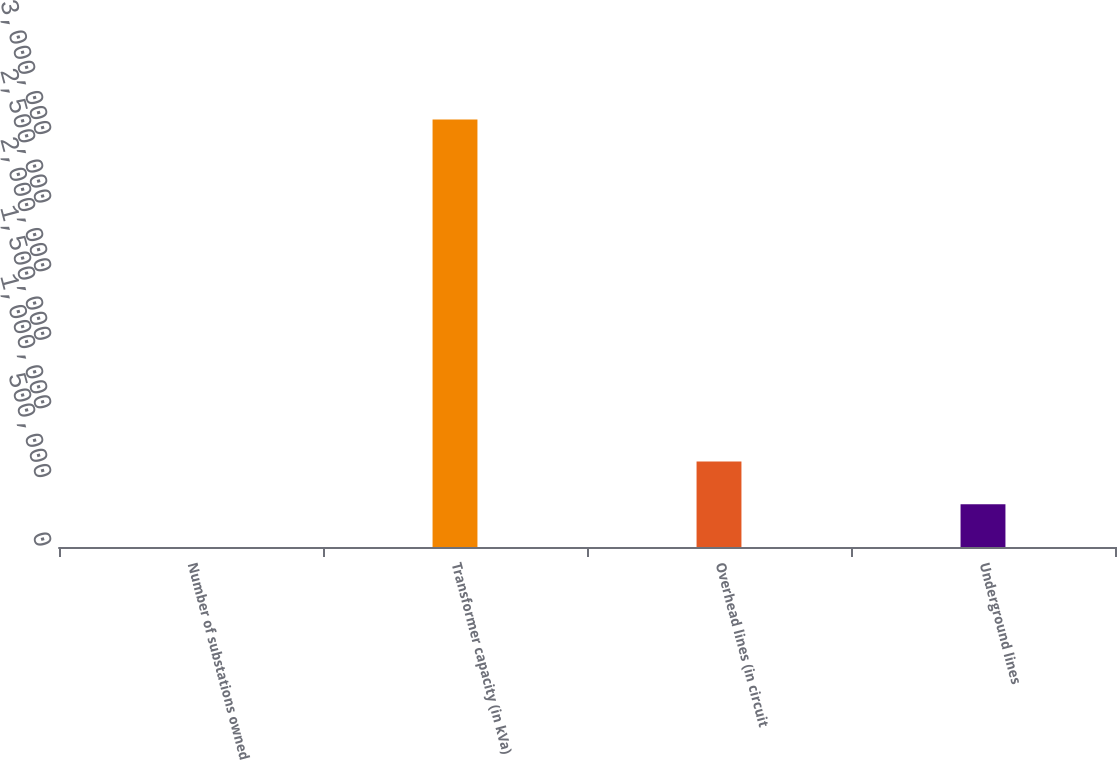Convert chart to OTSL. <chart><loc_0><loc_0><loc_500><loc_500><bar_chart><fcel>Number of substations owned<fcel>Transformer capacity (in kVa)<fcel>Overhead lines (in circuit<fcel>Underground lines<nl><fcel>19<fcel>3.117e+06<fcel>623415<fcel>311717<nl></chart> 